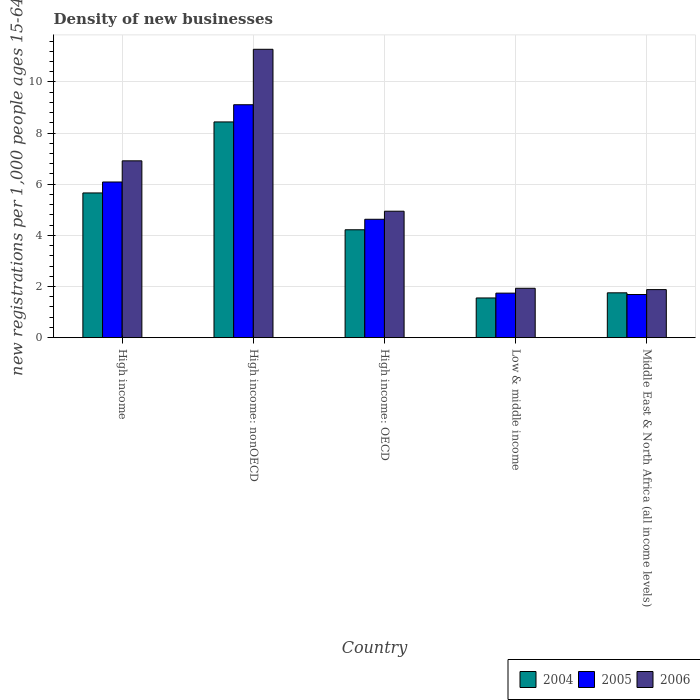How many different coloured bars are there?
Your answer should be compact. 3. Are the number of bars per tick equal to the number of legend labels?
Ensure brevity in your answer.  Yes. In how many cases, is the number of bars for a given country not equal to the number of legend labels?
Your answer should be very brief. 0. What is the number of new registrations in 2006 in High income: nonOECD?
Make the answer very short. 11.28. Across all countries, what is the maximum number of new registrations in 2004?
Your response must be concise. 8.44. Across all countries, what is the minimum number of new registrations in 2005?
Give a very brief answer. 1.69. In which country was the number of new registrations in 2005 maximum?
Offer a terse response. High income: nonOECD. In which country was the number of new registrations in 2005 minimum?
Offer a very short reply. Middle East & North Africa (all income levels). What is the total number of new registrations in 2005 in the graph?
Ensure brevity in your answer.  23.25. What is the difference between the number of new registrations in 2006 in High income and that in Low & middle income?
Ensure brevity in your answer.  4.98. What is the difference between the number of new registrations in 2005 in High income and the number of new registrations in 2006 in Low & middle income?
Your answer should be compact. 4.16. What is the average number of new registrations in 2004 per country?
Give a very brief answer. 4.32. What is the difference between the number of new registrations of/in 2004 and number of new registrations of/in 2005 in High income?
Give a very brief answer. -0.43. What is the ratio of the number of new registrations in 2006 in High income: nonOECD to that in Middle East & North Africa (all income levels)?
Provide a succinct answer. 6. Is the number of new registrations in 2004 in High income less than that in Middle East & North Africa (all income levels)?
Offer a very short reply. No. Is the difference between the number of new registrations in 2004 in High income and High income: nonOECD greater than the difference between the number of new registrations in 2005 in High income and High income: nonOECD?
Your answer should be very brief. Yes. What is the difference between the highest and the second highest number of new registrations in 2006?
Give a very brief answer. 6.33. What is the difference between the highest and the lowest number of new registrations in 2006?
Provide a short and direct response. 9.4. In how many countries, is the number of new registrations in 2004 greater than the average number of new registrations in 2004 taken over all countries?
Make the answer very short. 2. Is the sum of the number of new registrations in 2006 in High income and High income: nonOECD greater than the maximum number of new registrations in 2004 across all countries?
Your response must be concise. Yes. What does the 2nd bar from the left in High income represents?
Your response must be concise. 2005. Are all the bars in the graph horizontal?
Your answer should be compact. No. What is the difference between two consecutive major ticks on the Y-axis?
Ensure brevity in your answer.  2. Are the values on the major ticks of Y-axis written in scientific E-notation?
Offer a terse response. No. Does the graph contain any zero values?
Offer a terse response. No. How are the legend labels stacked?
Give a very brief answer. Horizontal. What is the title of the graph?
Offer a very short reply. Density of new businesses. What is the label or title of the Y-axis?
Keep it short and to the point. New registrations per 1,0 people ages 15-64. What is the new registrations per 1,000 people ages 15-64 in 2004 in High income?
Keep it short and to the point. 5.66. What is the new registrations per 1,000 people ages 15-64 of 2005 in High income?
Keep it short and to the point. 6.09. What is the new registrations per 1,000 people ages 15-64 of 2006 in High income?
Offer a very short reply. 6.91. What is the new registrations per 1,000 people ages 15-64 of 2004 in High income: nonOECD?
Your response must be concise. 8.44. What is the new registrations per 1,000 people ages 15-64 of 2005 in High income: nonOECD?
Provide a short and direct response. 9.11. What is the new registrations per 1,000 people ages 15-64 of 2006 in High income: nonOECD?
Your answer should be very brief. 11.28. What is the new registrations per 1,000 people ages 15-64 of 2004 in High income: OECD?
Offer a very short reply. 4.22. What is the new registrations per 1,000 people ages 15-64 of 2005 in High income: OECD?
Give a very brief answer. 4.63. What is the new registrations per 1,000 people ages 15-64 of 2006 in High income: OECD?
Offer a terse response. 4.94. What is the new registrations per 1,000 people ages 15-64 in 2004 in Low & middle income?
Keep it short and to the point. 1.55. What is the new registrations per 1,000 people ages 15-64 in 2005 in Low & middle income?
Offer a very short reply. 1.74. What is the new registrations per 1,000 people ages 15-64 in 2006 in Low & middle income?
Your answer should be compact. 1.93. What is the new registrations per 1,000 people ages 15-64 in 2004 in Middle East & North Africa (all income levels)?
Your response must be concise. 1.75. What is the new registrations per 1,000 people ages 15-64 in 2005 in Middle East & North Africa (all income levels)?
Your answer should be very brief. 1.69. What is the new registrations per 1,000 people ages 15-64 of 2006 in Middle East & North Africa (all income levels)?
Offer a very short reply. 1.88. Across all countries, what is the maximum new registrations per 1,000 people ages 15-64 in 2004?
Offer a very short reply. 8.44. Across all countries, what is the maximum new registrations per 1,000 people ages 15-64 in 2005?
Ensure brevity in your answer.  9.11. Across all countries, what is the maximum new registrations per 1,000 people ages 15-64 in 2006?
Offer a terse response. 11.28. Across all countries, what is the minimum new registrations per 1,000 people ages 15-64 of 2004?
Ensure brevity in your answer.  1.55. Across all countries, what is the minimum new registrations per 1,000 people ages 15-64 of 2005?
Your answer should be very brief. 1.69. Across all countries, what is the minimum new registrations per 1,000 people ages 15-64 of 2006?
Give a very brief answer. 1.88. What is the total new registrations per 1,000 people ages 15-64 of 2004 in the graph?
Give a very brief answer. 21.62. What is the total new registrations per 1,000 people ages 15-64 in 2005 in the graph?
Your answer should be very brief. 23.25. What is the total new registrations per 1,000 people ages 15-64 in 2006 in the graph?
Offer a terse response. 26.95. What is the difference between the new registrations per 1,000 people ages 15-64 of 2004 in High income and that in High income: nonOECD?
Offer a terse response. -2.78. What is the difference between the new registrations per 1,000 people ages 15-64 in 2005 in High income and that in High income: nonOECD?
Ensure brevity in your answer.  -3.02. What is the difference between the new registrations per 1,000 people ages 15-64 of 2006 in High income and that in High income: nonOECD?
Provide a short and direct response. -4.36. What is the difference between the new registrations per 1,000 people ages 15-64 of 2004 in High income and that in High income: OECD?
Offer a very short reply. 1.44. What is the difference between the new registrations per 1,000 people ages 15-64 of 2005 in High income and that in High income: OECD?
Make the answer very short. 1.46. What is the difference between the new registrations per 1,000 people ages 15-64 of 2006 in High income and that in High income: OECD?
Offer a very short reply. 1.97. What is the difference between the new registrations per 1,000 people ages 15-64 in 2004 in High income and that in Low & middle income?
Provide a short and direct response. 4.11. What is the difference between the new registrations per 1,000 people ages 15-64 of 2005 in High income and that in Low & middle income?
Make the answer very short. 4.35. What is the difference between the new registrations per 1,000 people ages 15-64 of 2006 in High income and that in Low & middle income?
Your answer should be compact. 4.98. What is the difference between the new registrations per 1,000 people ages 15-64 of 2004 in High income and that in Middle East & North Africa (all income levels)?
Keep it short and to the point. 3.91. What is the difference between the new registrations per 1,000 people ages 15-64 in 2005 in High income and that in Middle East & North Africa (all income levels)?
Offer a very short reply. 4.4. What is the difference between the new registrations per 1,000 people ages 15-64 in 2006 in High income and that in Middle East & North Africa (all income levels)?
Offer a terse response. 5.04. What is the difference between the new registrations per 1,000 people ages 15-64 of 2004 in High income: nonOECD and that in High income: OECD?
Your response must be concise. 4.22. What is the difference between the new registrations per 1,000 people ages 15-64 in 2005 in High income: nonOECD and that in High income: OECD?
Make the answer very short. 4.48. What is the difference between the new registrations per 1,000 people ages 15-64 in 2006 in High income: nonOECD and that in High income: OECD?
Give a very brief answer. 6.33. What is the difference between the new registrations per 1,000 people ages 15-64 in 2004 in High income: nonOECD and that in Low & middle income?
Offer a very short reply. 6.88. What is the difference between the new registrations per 1,000 people ages 15-64 of 2005 in High income: nonOECD and that in Low & middle income?
Provide a succinct answer. 7.37. What is the difference between the new registrations per 1,000 people ages 15-64 of 2006 in High income: nonOECD and that in Low & middle income?
Your response must be concise. 9.34. What is the difference between the new registrations per 1,000 people ages 15-64 in 2004 in High income: nonOECD and that in Middle East & North Africa (all income levels)?
Ensure brevity in your answer.  6.68. What is the difference between the new registrations per 1,000 people ages 15-64 of 2005 in High income: nonOECD and that in Middle East & North Africa (all income levels)?
Keep it short and to the point. 7.42. What is the difference between the new registrations per 1,000 people ages 15-64 in 2006 in High income: nonOECD and that in Middle East & North Africa (all income levels)?
Your answer should be very brief. 9.4. What is the difference between the new registrations per 1,000 people ages 15-64 of 2004 in High income: OECD and that in Low & middle income?
Your response must be concise. 2.67. What is the difference between the new registrations per 1,000 people ages 15-64 of 2005 in High income: OECD and that in Low & middle income?
Provide a succinct answer. 2.89. What is the difference between the new registrations per 1,000 people ages 15-64 in 2006 in High income: OECD and that in Low & middle income?
Offer a very short reply. 3.01. What is the difference between the new registrations per 1,000 people ages 15-64 of 2004 in High income: OECD and that in Middle East & North Africa (all income levels)?
Provide a succinct answer. 2.47. What is the difference between the new registrations per 1,000 people ages 15-64 in 2005 in High income: OECD and that in Middle East & North Africa (all income levels)?
Give a very brief answer. 2.94. What is the difference between the new registrations per 1,000 people ages 15-64 of 2006 in High income: OECD and that in Middle East & North Africa (all income levels)?
Your answer should be compact. 3.07. What is the difference between the new registrations per 1,000 people ages 15-64 in 2004 in Low & middle income and that in Middle East & North Africa (all income levels)?
Provide a succinct answer. -0.2. What is the difference between the new registrations per 1,000 people ages 15-64 in 2005 in Low & middle income and that in Middle East & North Africa (all income levels)?
Offer a very short reply. 0.05. What is the difference between the new registrations per 1,000 people ages 15-64 of 2006 in Low & middle income and that in Middle East & North Africa (all income levels)?
Provide a succinct answer. 0.05. What is the difference between the new registrations per 1,000 people ages 15-64 in 2004 in High income and the new registrations per 1,000 people ages 15-64 in 2005 in High income: nonOECD?
Offer a very short reply. -3.45. What is the difference between the new registrations per 1,000 people ages 15-64 in 2004 in High income and the new registrations per 1,000 people ages 15-64 in 2006 in High income: nonOECD?
Your response must be concise. -5.62. What is the difference between the new registrations per 1,000 people ages 15-64 of 2005 in High income and the new registrations per 1,000 people ages 15-64 of 2006 in High income: nonOECD?
Provide a succinct answer. -5.19. What is the difference between the new registrations per 1,000 people ages 15-64 of 2004 in High income and the new registrations per 1,000 people ages 15-64 of 2005 in High income: OECD?
Your answer should be compact. 1.03. What is the difference between the new registrations per 1,000 people ages 15-64 of 2004 in High income and the new registrations per 1,000 people ages 15-64 of 2006 in High income: OECD?
Offer a terse response. 0.71. What is the difference between the new registrations per 1,000 people ages 15-64 of 2005 in High income and the new registrations per 1,000 people ages 15-64 of 2006 in High income: OECD?
Your answer should be compact. 1.14. What is the difference between the new registrations per 1,000 people ages 15-64 of 2004 in High income and the new registrations per 1,000 people ages 15-64 of 2005 in Low & middle income?
Make the answer very short. 3.92. What is the difference between the new registrations per 1,000 people ages 15-64 of 2004 in High income and the new registrations per 1,000 people ages 15-64 of 2006 in Low & middle income?
Your answer should be compact. 3.73. What is the difference between the new registrations per 1,000 people ages 15-64 of 2005 in High income and the new registrations per 1,000 people ages 15-64 of 2006 in Low & middle income?
Provide a short and direct response. 4.16. What is the difference between the new registrations per 1,000 people ages 15-64 in 2004 in High income and the new registrations per 1,000 people ages 15-64 in 2005 in Middle East & North Africa (all income levels)?
Offer a very short reply. 3.97. What is the difference between the new registrations per 1,000 people ages 15-64 of 2004 in High income and the new registrations per 1,000 people ages 15-64 of 2006 in Middle East & North Africa (all income levels)?
Your answer should be compact. 3.78. What is the difference between the new registrations per 1,000 people ages 15-64 of 2005 in High income and the new registrations per 1,000 people ages 15-64 of 2006 in Middle East & North Africa (all income levels)?
Your answer should be compact. 4.21. What is the difference between the new registrations per 1,000 people ages 15-64 of 2004 in High income: nonOECD and the new registrations per 1,000 people ages 15-64 of 2005 in High income: OECD?
Ensure brevity in your answer.  3.81. What is the difference between the new registrations per 1,000 people ages 15-64 of 2004 in High income: nonOECD and the new registrations per 1,000 people ages 15-64 of 2006 in High income: OECD?
Keep it short and to the point. 3.49. What is the difference between the new registrations per 1,000 people ages 15-64 in 2005 in High income: nonOECD and the new registrations per 1,000 people ages 15-64 in 2006 in High income: OECD?
Keep it short and to the point. 4.16. What is the difference between the new registrations per 1,000 people ages 15-64 in 2004 in High income: nonOECD and the new registrations per 1,000 people ages 15-64 in 2005 in Low & middle income?
Provide a short and direct response. 6.69. What is the difference between the new registrations per 1,000 people ages 15-64 of 2004 in High income: nonOECD and the new registrations per 1,000 people ages 15-64 of 2006 in Low & middle income?
Offer a terse response. 6.5. What is the difference between the new registrations per 1,000 people ages 15-64 of 2005 in High income: nonOECD and the new registrations per 1,000 people ages 15-64 of 2006 in Low & middle income?
Ensure brevity in your answer.  7.18. What is the difference between the new registrations per 1,000 people ages 15-64 in 2004 in High income: nonOECD and the new registrations per 1,000 people ages 15-64 in 2005 in Middle East & North Africa (all income levels)?
Provide a succinct answer. 6.75. What is the difference between the new registrations per 1,000 people ages 15-64 of 2004 in High income: nonOECD and the new registrations per 1,000 people ages 15-64 of 2006 in Middle East & North Africa (all income levels)?
Your answer should be compact. 6.56. What is the difference between the new registrations per 1,000 people ages 15-64 of 2005 in High income: nonOECD and the new registrations per 1,000 people ages 15-64 of 2006 in Middle East & North Africa (all income levels)?
Your response must be concise. 7.23. What is the difference between the new registrations per 1,000 people ages 15-64 in 2004 in High income: OECD and the new registrations per 1,000 people ages 15-64 in 2005 in Low & middle income?
Ensure brevity in your answer.  2.48. What is the difference between the new registrations per 1,000 people ages 15-64 of 2004 in High income: OECD and the new registrations per 1,000 people ages 15-64 of 2006 in Low & middle income?
Give a very brief answer. 2.29. What is the difference between the new registrations per 1,000 people ages 15-64 of 2005 in High income: OECD and the new registrations per 1,000 people ages 15-64 of 2006 in Low & middle income?
Ensure brevity in your answer.  2.7. What is the difference between the new registrations per 1,000 people ages 15-64 of 2004 in High income: OECD and the new registrations per 1,000 people ages 15-64 of 2005 in Middle East & North Africa (all income levels)?
Offer a very short reply. 2.53. What is the difference between the new registrations per 1,000 people ages 15-64 of 2004 in High income: OECD and the new registrations per 1,000 people ages 15-64 of 2006 in Middle East & North Africa (all income levels)?
Provide a short and direct response. 2.34. What is the difference between the new registrations per 1,000 people ages 15-64 in 2005 in High income: OECD and the new registrations per 1,000 people ages 15-64 in 2006 in Middle East & North Africa (all income levels)?
Provide a short and direct response. 2.75. What is the difference between the new registrations per 1,000 people ages 15-64 of 2004 in Low & middle income and the new registrations per 1,000 people ages 15-64 of 2005 in Middle East & North Africa (all income levels)?
Provide a succinct answer. -0.13. What is the difference between the new registrations per 1,000 people ages 15-64 of 2004 in Low & middle income and the new registrations per 1,000 people ages 15-64 of 2006 in Middle East & North Africa (all income levels)?
Keep it short and to the point. -0.33. What is the difference between the new registrations per 1,000 people ages 15-64 in 2005 in Low & middle income and the new registrations per 1,000 people ages 15-64 in 2006 in Middle East & North Africa (all income levels)?
Ensure brevity in your answer.  -0.14. What is the average new registrations per 1,000 people ages 15-64 in 2004 per country?
Your answer should be very brief. 4.32. What is the average new registrations per 1,000 people ages 15-64 of 2005 per country?
Your answer should be compact. 4.65. What is the average new registrations per 1,000 people ages 15-64 of 2006 per country?
Provide a succinct answer. 5.39. What is the difference between the new registrations per 1,000 people ages 15-64 in 2004 and new registrations per 1,000 people ages 15-64 in 2005 in High income?
Keep it short and to the point. -0.43. What is the difference between the new registrations per 1,000 people ages 15-64 in 2004 and new registrations per 1,000 people ages 15-64 in 2006 in High income?
Offer a very short reply. -1.26. What is the difference between the new registrations per 1,000 people ages 15-64 in 2005 and new registrations per 1,000 people ages 15-64 in 2006 in High income?
Your answer should be very brief. -0.83. What is the difference between the new registrations per 1,000 people ages 15-64 in 2004 and new registrations per 1,000 people ages 15-64 in 2005 in High income: nonOECD?
Your answer should be very brief. -0.67. What is the difference between the new registrations per 1,000 people ages 15-64 of 2004 and new registrations per 1,000 people ages 15-64 of 2006 in High income: nonOECD?
Ensure brevity in your answer.  -2.84. What is the difference between the new registrations per 1,000 people ages 15-64 of 2005 and new registrations per 1,000 people ages 15-64 of 2006 in High income: nonOECD?
Offer a terse response. -2.17. What is the difference between the new registrations per 1,000 people ages 15-64 in 2004 and new registrations per 1,000 people ages 15-64 in 2005 in High income: OECD?
Your answer should be very brief. -0.41. What is the difference between the new registrations per 1,000 people ages 15-64 in 2004 and new registrations per 1,000 people ages 15-64 in 2006 in High income: OECD?
Your answer should be very brief. -0.73. What is the difference between the new registrations per 1,000 people ages 15-64 in 2005 and new registrations per 1,000 people ages 15-64 in 2006 in High income: OECD?
Make the answer very short. -0.32. What is the difference between the new registrations per 1,000 people ages 15-64 in 2004 and new registrations per 1,000 people ages 15-64 in 2005 in Low & middle income?
Give a very brief answer. -0.19. What is the difference between the new registrations per 1,000 people ages 15-64 of 2004 and new registrations per 1,000 people ages 15-64 of 2006 in Low & middle income?
Offer a terse response. -0.38. What is the difference between the new registrations per 1,000 people ages 15-64 of 2005 and new registrations per 1,000 people ages 15-64 of 2006 in Low & middle income?
Your answer should be very brief. -0.19. What is the difference between the new registrations per 1,000 people ages 15-64 of 2004 and new registrations per 1,000 people ages 15-64 of 2005 in Middle East & North Africa (all income levels)?
Your answer should be very brief. 0.07. What is the difference between the new registrations per 1,000 people ages 15-64 of 2004 and new registrations per 1,000 people ages 15-64 of 2006 in Middle East & North Africa (all income levels)?
Offer a very short reply. -0.13. What is the difference between the new registrations per 1,000 people ages 15-64 in 2005 and new registrations per 1,000 people ages 15-64 in 2006 in Middle East & North Africa (all income levels)?
Provide a succinct answer. -0.19. What is the ratio of the new registrations per 1,000 people ages 15-64 of 2004 in High income to that in High income: nonOECD?
Ensure brevity in your answer.  0.67. What is the ratio of the new registrations per 1,000 people ages 15-64 of 2005 in High income to that in High income: nonOECD?
Your response must be concise. 0.67. What is the ratio of the new registrations per 1,000 people ages 15-64 of 2006 in High income to that in High income: nonOECD?
Ensure brevity in your answer.  0.61. What is the ratio of the new registrations per 1,000 people ages 15-64 of 2004 in High income to that in High income: OECD?
Provide a succinct answer. 1.34. What is the ratio of the new registrations per 1,000 people ages 15-64 in 2005 in High income to that in High income: OECD?
Your answer should be very brief. 1.31. What is the ratio of the new registrations per 1,000 people ages 15-64 in 2006 in High income to that in High income: OECD?
Offer a terse response. 1.4. What is the ratio of the new registrations per 1,000 people ages 15-64 in 2004 in High income to that in Low & middle income?
Provide a succinct answer. 3.64. What is the ratio of the new registrations per 1,000 people ages 15-64 in 2005 in High income to that in Low & middle income?
Provide a succinct answer. 3.5. What is the ratio of the new registrations per 1,000 people ages 15-64 in 2006 in High income to that in Low & middle income?
Make the answer very short. 3.58. What is the ratio of the new registrations per 1,000 people ages 15-64 of 2004 in High income to that in Middle East & North Africa (all income levels)?
Give a very brief answer. 3.23. What is the ratio of the new registrations per 1,000 people ages 15-64 of 2005 in High income to that in Middle East & North Africa (all income levels)?
Provide a short and direct response. 3.61. What is the ratio of the new registrations per 1,000 people ages 15-64 of 2006 in High income to that in Middle East & North Africa (all income levels)?
Give a very brief answer. 3.68. What is the ratio of the new registrations per 1,000 people ages 15-64 of 2004 in High income: nonOECD to that in High income: OECD?
Offer a very short reply. 2. What is the ratio of the new registrations per 1,000 people ages 15-64 of 2005 in High income: nonOECD to that in High income: OECD?
Offer a very short reply. 1.97. What is the ratio of the new registrations per 1,000 people ages 15-64 of 2006 in High income: nonOECD to that in High income: OECD?
Your answer should be very brief. 2.28. What is the ratio of the new registrations per 1,000 people ages 15-64 of 2004 in High income: nonOECD to that in Low & middle income?
Offer a terse response. 5.43. What is the ratio of the new registrations per 1,000 people ages 15-64 in 2005 in High income: nonOECD to that in Low & middle income?
Your answer should be very brief. 5.23. What is the ratio of the new registrations per 1,000 people ages 15-64 of 2006 in High income: nonOECD to that in Low & middle income?
Make the answer very short. 5.84. What is the ratio of the new registrations per 1,000 people ages 15-64 of 2004 in High income: nonOECD to that in Middle East & North Africa (all income levels)?
Give a very brief answer. 4.81. What is the ratio of the new registrations per 1,000 people ages 15-64 in 2005 in High income: nonOECD to that in Middle East & North Africa (all income levels)?
Ensure brevity in your answer.  5.4. What is the ratio of the new registrations per 1,000 people ages 15-64 of 2006 in High income: nonOECD to that in Middle East & North Africa (all income levels)?
Give a very brief answer. 6. What is the ratio of the new registrations per 1,000 people ages 15-64 in 2004 in High income: OECD to that in Low & middle income?
Your answer should be compact. 2.72. What is the ratio of the new registrations per 1,000 people ages 15-64 of 2005 in High income: OECD to that in Low & middle income?
Make the answer very short. 2.66. What is the ratio of the new registrations per 1,000 people ages 15-64 of 2006 in High income: OECD to that in Low & middle income?
Offer a terse response. 2.56. What is the ratio of the new registrations per 1,000 people ages 15-64 in 2004 in High income: OECD to that in Middle East & North Africa (all income levels)?
Provide a short and direct response. 2.41. What is the ratio of the new registrations per 1,000 people ages 15-64 of 2005 in High income: OECD to that in Middle East & North Africa (all income levels)?
Your response must be concise. 2.74. What is the ratio of the new registrations per 1,000 people ages 15-64 in 2006 in High income: OECD to that in Middle East & North Africa (all income levels)?
Make the answer very short. 2.63. What is the ratio of the new registrations per 1,000 people ages 15-64 in 2004 in Low & middle income to that in Middle East & North Africa (all income levels)?
Your answer should be very brief. 0.89. What is the ratio of the new registrations per 1,000 people ages 15-64 in 2005 in Low & middle income to that in Middle East & North Africa (all income levels)?
Make the answer very short. 1.03. What is the ratio of the new registrations per 1,000 people ages 15-64 of 2006 in Low & middle income to that in Middle East & North Africa (all income levels)?
Keep it short and to the point. 1.03. What is the difference between the highest and the second highest new registrations per 1,000 people ages 15-64 in 2004?
Offer a terse response. 2.78. What is the difference between the highest and the second highest new registrations per 1,000 people ages 15-64 of 2005?
Provide a succinct answer. 3.02. What is the difference between the highest and the second highest new registrations per 1,000 people ages 15-64 in 2006?
Provide a short and direct response. 4.36. What is the difference between the highest and the lowest new registrations per 1,000 people ages 15-64 in 2004?
Offer a very short reply. 6.88. What is the difference between the highest and the lowest new registrations per 1,000 people ages 15-64 of 2005?
Make the answer very short. 7.42. What is the difference between the highest and the lowest new registrations per 1,000 people ages 15-64 in 2006?
Your response must be concise. 9.4. 